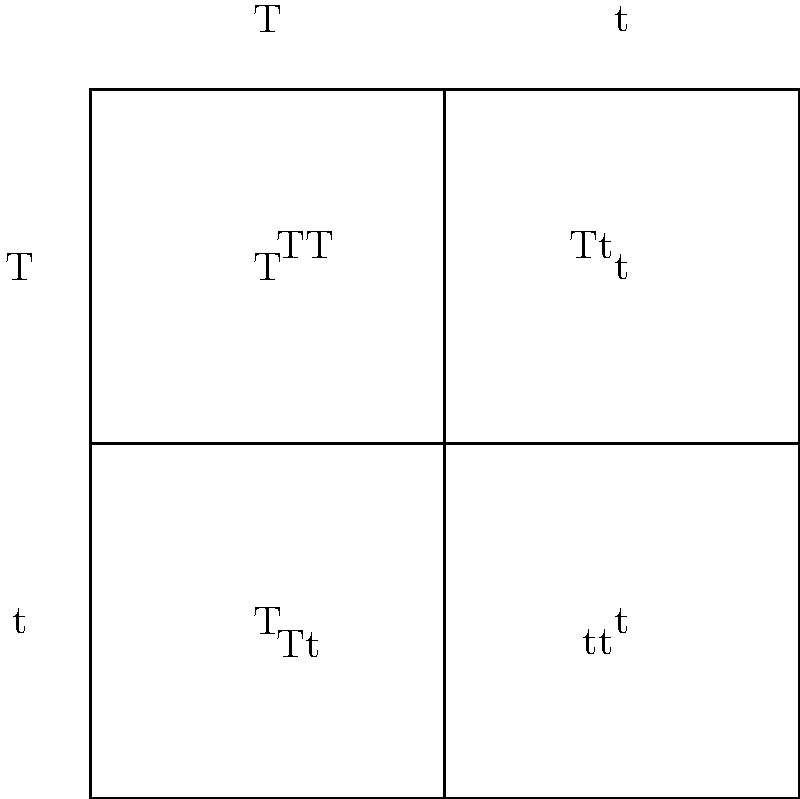In a genetic cross between two heterozygous individuals (Tt x Tt) for a trait controlled by a single gene, what is the probability of offspring having the homozygous recessive genotype (tt)? To solve this problem, we'll use a Punnett square and follow these steps:

1. Identify the genotypes of the parents: Both parents are heterozygous (Tt).

2. Set up the Punnett square:
   - Place one parent's alleles (T and t) along the top
   - Place the other parent's alleles (T and t) along the left side

3. Fill in the Punnett square by combining the alleles:
   - TT (top left)
   - Tt (top right)
   - Tt (bottom left)
   - tt (bottom right)

4. Count the number of each genotype:
   - TT: 1
   - Tt: 2
   - tt: 1

5. Calculate the probability:
   - Total number of possible outcomes: 4
   - Number of tt outcomes: 1
   - Probability = 1/4 = 0.25 or 25%

The homozygous recessive genotype (tt) appears in 1 out of 4 possible outcomes.
Answer: 1/4 or 25% 